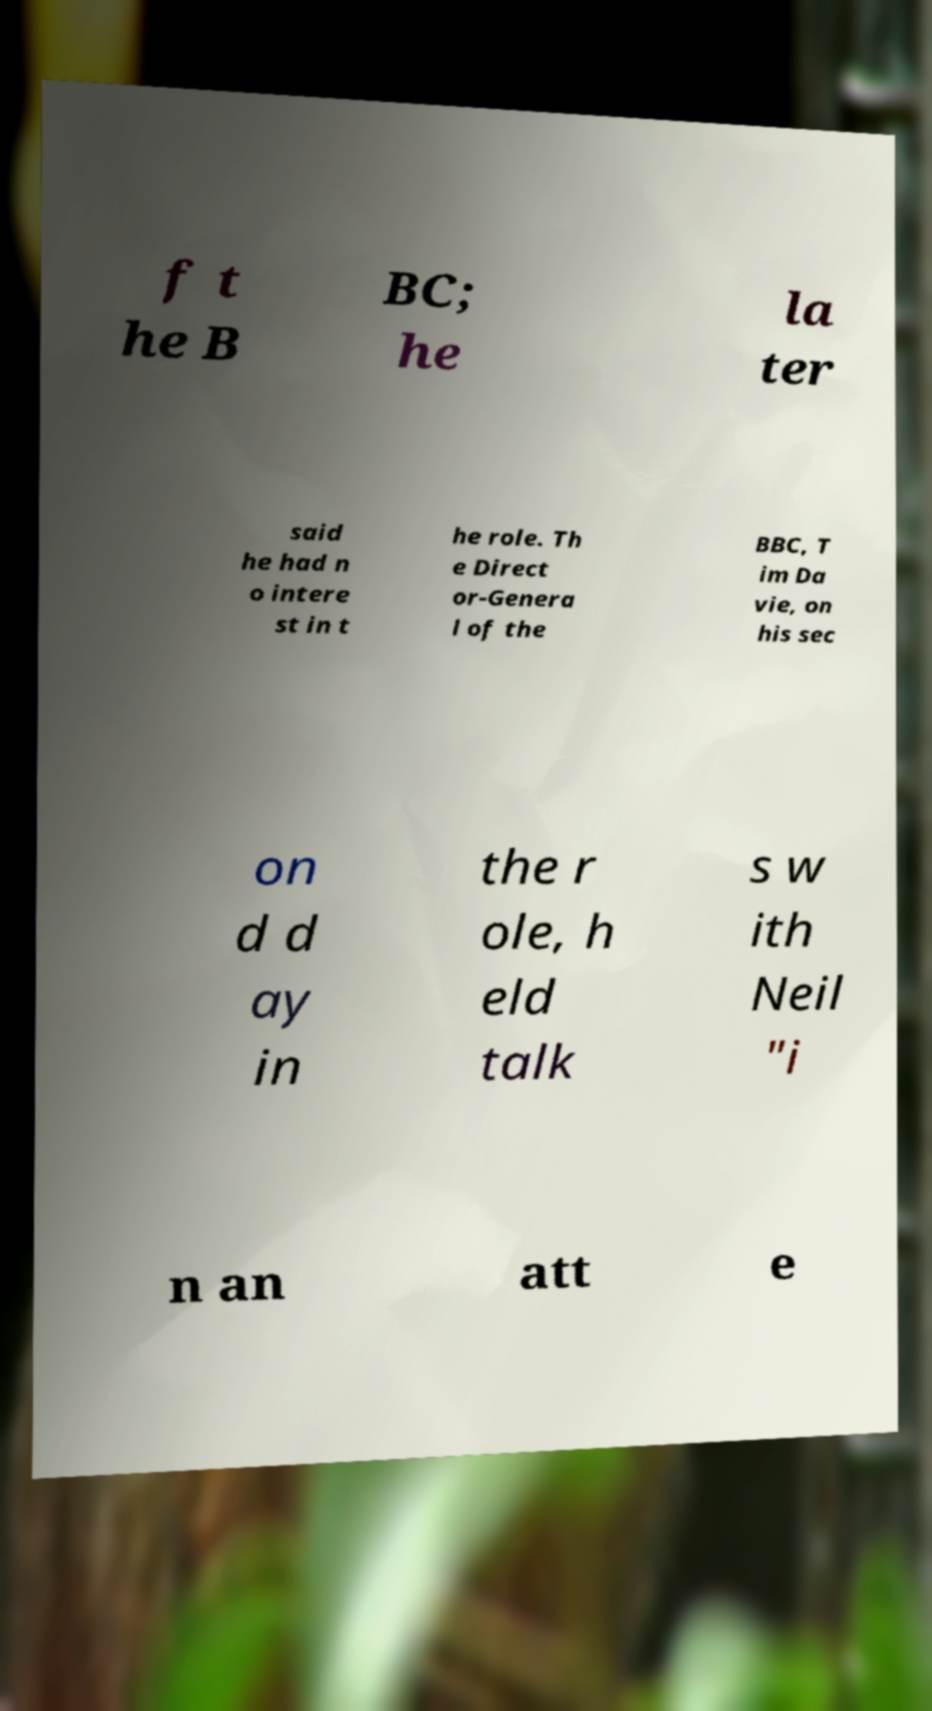Could you assist in decoding the text presented in this image and type it out clearly? f t he B BC; he la ter said he had n o intere st in t he role. Th e Direct or-Genera l of the BBC, T im Da vie, on his sec on d d ay in the r ole, h eld talk s w ith Neil "i n an att e 